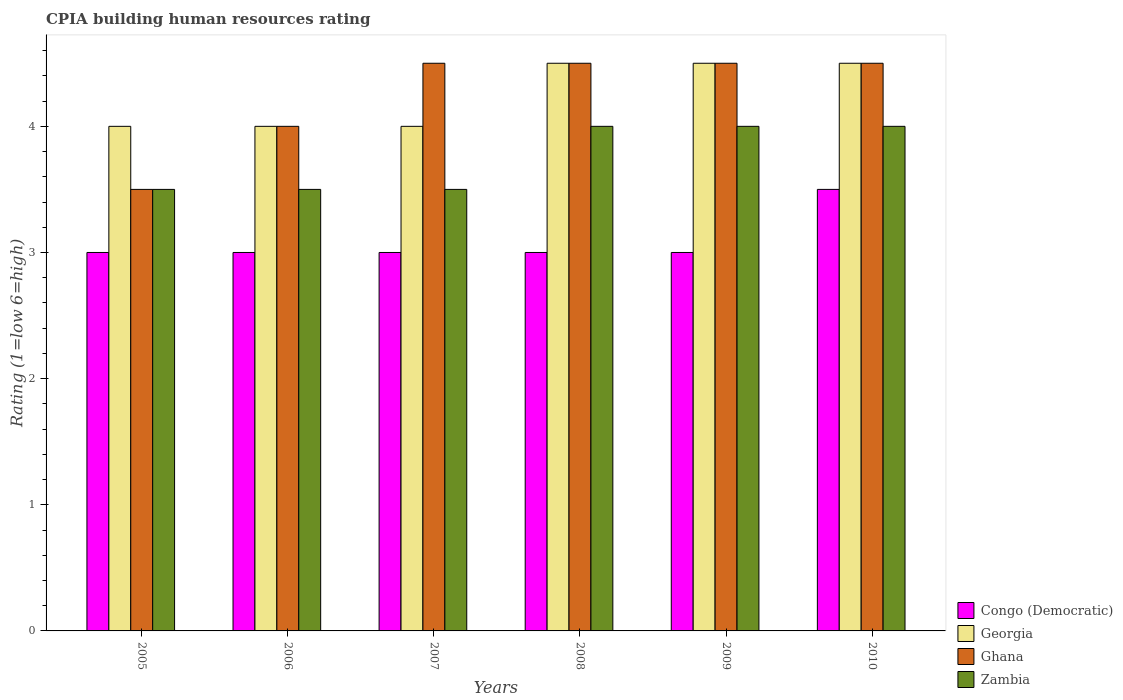How many different coloured bars are there?
Your response must be concise. 4. How many groups of bars are there?
Keep it short and to the point. 6. Are the number of bars per tick equal to the number of legend labels?
Your response must be concise. Yes. In how many cases, is the number of bars for a given year not equal to the number of legend labels?
Make the answer very short. 0. In which year was the CPIA rating in Zambia minimum?
Make the answer very short. 2005. What is the difference between the CPIA rating in Georgia in 2008 and the CPIA rating in Ghana in 2006?
Provide a succinct answer. 0.5. What is the average CPIA rating in Ghana per year?
Make the answer very short. 4.25. In the year 2008, what is the difference between the CPIA rating in Ghana and CPIA rating in Zambia?
Ensure brevity in your answer.  0.5. Is the difference between the CPIA rating in Ghana in 2005 and 2008 greater than the difference between the CPIA rating in Zambia in 2005 and 2008?
Your answer should be compact. No. What is the difference between the highest and the second highest CPIA rating in Congo (Democratic)?
Offer a very short reply. 0.5. What does the 1st bar from the left in 2010 represents?
Offer a terse response. Congo (Democratic). What does the 4th bar from the right in 2006 represents?
Provide a short and direct response. Congo (Democratic). How many bars are there?
Provide a short and direct response. 24. What is the difference between two consecutive major ticks on the Y-axis?
Give a very brief answer. 1. Are the values on the major ticks of Y-axis written in scientific E-notation?
Your answer should be very brief. No. Does the graph contain any zero values?
Your answer should be very brief. No. Does the graph contain grids?
Give a very brief answer. No. What is the title of the graph?
Keep it short and to the point. CPIA building human resources rating. Does "France" appear as one of the legend labels in the graph?
Ensure brevity in your answer.  No. What is the label or title of the X-axis?
Make the answer very short. Years. What is the Rating (1=low 6=high) in Georgia in 2005?
Offer a very short reply. 4. What is the Rating (1=low 6=high) in Zambia in 2005?
Your answer should be very brief. 3.5. What is the Rating (1=low 6=high) of Congo (Democratic) in 2006?
Provide a succinct answer. 3. What is the Rating (1=low 6=high) in Georgia in 2006?
Offer a very short reply. 4. What is the Rating (1=low 6=high) of Ghana in 2006?
Offer a terse response. 4. What is the Rating (1=low 6=high) in Zambia in 2006?
Provide a succinct answer. 3.5. What is the Rating (1=low 6=high) in Congo (Democratic) in 2007?
Your answer should be compact. 3. What is the Rating (1=low 6=high) of Ghana in 2007?
Make the answer very short. 4.5. What is the Rating (1=low 6=high) in Congo (Democratic) in 2008?
Ensure brevity in your answer.  3. What is the Rating (1=low 6=high) in Georgia in 2008?
Your response must be concise. 4.5. What is the Rating (1=low 6=high) in Congo (Democratic) in 2009?
Make the answer very short. 3. What is the Rating (1=low 6=high) of Georgia in 2009?
Offer a very short reply. 4.5. What is the Rating (1=low 6=high) of Ghana in 2009?
Offer a very short reply. 4.5. What is the Rating (1=low 6=high) in Zambia in 2009?
Provide a succinct answer. 4. What is the Rating (1=low 6=high) of Ghana in 2010?
Offer a very short reply. 4.5. What is the Rating (1=low 6=high) in Zambia in 2010?
Your response must be concise. 4. Across all years, what is the maximum Rating (1=low 6=high) of Ghana?
Your answer should be very brief. 4.5. Across all years, what is the maximum Rating (1=low 6=high) in Zambia?
Your answer should be compact. 4. Across all years, what is the minimum Rating (1=low 6=high) of Georgia?
Give a very brief answer. 4. Across all years, what is the minimum Rating (1=low 6=high) of Ghana?
Provide a succinct answer. 3.5. What is the difference between the Rating (1=low 6=high) in Congo (Democratic) in 2005 and that in 2006?
Offer a terse response. 0. What is the difference between the Rating (1=low 6=high) in Georgia in 2005 and that in 2006?
Make the answer very short. 0. What is the difference between the Rating (1=low 6=high) of Ghana in 2005 and that in 2006?
Your response must be concise. -0.5. What is the difference between the Rating (1=low 6=high) of Zambia in 2005 and that in 2006?
Keep it short and to the point. 0. What is the difference between the Rating (1=low 6=high) in Congo (Democratic) in 2005 and that in 2007?
Give a very brief answer. 0. What is the difference between the Rating (1=low 6=high) in Ghana in 2005 and that in 2007?
Your response must be concise. -1. What is the difference between the Rating (1=low 6=high) in Zambia in 2005 and that in 2007?
Give a very brief answer. 0. What is the difference between the Rating (1=low 6=high) of Ghana in 2005 and that in 2008?
Your answer should be compact. -1. What is the difference between the Rating (1=low 6=high) in Zambia in 2005 and that in 2008?
Your answer should be compact. -0.5. What is the difference between the Rating (1=low 6=high) in Congo (Democratic) in 2005 and that in 2009?
Your response must be concise. 0. What is the difference between the Rating (1=low 6=high) of Georgia in 2005 and that in 2009?
Offer a terse response. -0.5. What is the difference between the Rating (1=low 6=high) of Ghana in 2005 and that in 2010?
Provide a short and direct response. -1. What is the difference between the Rating (1=low 6=high) of Congo (Democratic) in 2006 and that in 2007?
Provide a succinct answer. 0. What is the difference between the Rating (1=low 6=high) in Ghana in 2006 and that in 2007?
Keep it short and to the point. -0.5. What is the difference between the Rating (1=low 6=high) in Zambia in 2006 and that in 2007?
Provide a short and direct response. 0. What is the difference between the Rating (1=low 6=high) of Congo (Democratic) in 2006 and that in 2008?
Your answer should be very brief. 0. What is the difference between the Rating (1=low 6=high) in Congo (Democratic) in 2006 and that in 2009?
Offer a very short reply. 0. What is the difference between the Rating (1=low 6=high) of Zambia in 2006 and that in 2009?
Your response must be concise. -0.5. What is the difference between the Rating (1=low 6=high) of Georgia in 2006 and that in 2010?
Offer a very short reply. -0.5. What is the difference between the Rating (1=low 6=high) in Zambia in 2006 and that in 2010?
Your response must be concise. -0.5. What is the difference between the Rating (1=low 6=high) in Congo (Democratic) in 2007 and that in 2008?
Ensure brevity in your answer.  0. What is the difference between the Rating (1=low 6=high) in Ghana in 2007 and that in 2008?
Your response must be concise. 0. What is the difference between the Rating (1=low 6=high) in Zambia in 2007 and that in 2008?
Provide a short and direct response. -0.5. What is the difference between the Rating (1=low 6=high) in Congo (Democratic) in 2007 and that in 2009?
Provide a succinct answer. 0. What is the difference between the Rating (1=low 6=high) in Georgia in 2007 and that in 2009?
Your answer should be compact. -0.5. What is the difference between the Rating (1=low 6=high) in Congo (Democratic) in 2007 and that in 2010?
Offer a very short reply. -0.5. What is the difference between the Rating (1=low 6=high) of Georgia in 2007 and that in 2010?
Your answer should be very brief. -0.5. What is the difference between the Rating (1=low 6=high) of Zambia in 2007 and that in 2010?
Offer a terse response. -0.5. What is the difference between the Rating (1=low 6=high) of Congo (Democratic) in 2008 and that in 2009?
Offer a very short reply. 0. What is the difference between the Rating (1=low 6=high) of Ghana in 2008 and that in 2009?
Provide a short and direct response. 0. What is the difference between the Rating (1=low 6=high) in Zambia in 2008 and that in 2009?
Give a very brief answer. 0. What is the difference between the Rating (1=low 6=high) in Congo (Democratic) in 2008 and that in 2010?
Offer a terse response. -0.5. What is the difference between the Rating (1=low 6=high) of Georgia in 2008 and that in 2010?
Provide a succinct answer. 0. What is the difference between the Rating (1=low 6=high) in Ghana in 2009 and that in 2010?
Provide a succinct answer. 0. What is the difference between the Rating (1=low 6=high) in Zambia in 2009 and that in 2010?
Your answer should be compact. 0. What is the difference between the Rating (1=low 6=high) in Congo (Democratic) in 2005 and the Rating (1=low 6=high) in Georgia in 2006?
Give a very brief answer. -1. What is the difference between the Rating (1=low 6=high) of Congo (Democratic) in 2005 and the Rating (1=low 6=high) of Zambia in 2006?
Ensure brevity in your answer.  -0.5. What is the difference between the Rating (1=low 6=high) of Congo (Democratic) in 2005 and the Rating (1=low 6=high) of Zambia in 2007?
Provide a succinct answer. -0.5. What is the difference between the Rating (1=low 6=high) of Georgia in 2005 and the Rating (1=low 6=high) of Zambia in 2007?
Keep it short and to the point. 0.5. What is the difference between the Rating (1=low 6=high) of Ghana in 2005 and the Rating (1=low 6=high) of Zambia in 2007?
Offer a very short reply. 0. What is the difference between the Rating (1=low 6=high) in Congo (Democratic) in 2005 and the Rating (1=low 6=high) in Zambia in 2008?
Your response must be concise. -1. What is the difference between the Rating (1=low 6=high) of Georgia in 2005 and the Rating (1=low 6=high) of Ghana in 2008?
Your answer should be compact. -0.5. What is the difference between the Rating (1=low 6=high) of Congo (Democratic) in 2005 and the Rating (1=low 6=high) of Georgia in 2009?
Keep it short and to the point. -1.5. What is the difference between the Rating (1=low 6=high) of Congo (Democratic) in 2005 and the Rating (1=low 6=high) of Ghana in 2009?
Your answer should be compact. -1.5. What is the difference between the Rating (1=low 6=high) of Congo (Democratic) in 2005 and the Rating (1=low 6=high) of Zambia in 2009?
Provide a succinct answer. -1. What is the difference between the Rating (1=low 6=high) in Ghana in 2005 and the Rating (1=low 6=high) in Zambia in 2009?
Your response must be concise. -0.5. What is the difference between the Rating (1=low 6=high) in Georgia in 2005 and the Rating (1=low 6=high) in Zambia in 2010?
Offer a very short reply. 0. What is the difference between the Rating (1=low 6=high) of Ghana in 2005 and the Rating (1=low 6=high) of Zambia in 2010?
Your answer should be very brief. -0.5. What is the difference between the Rating (1=low 6=high) in Congo (Democratic) in 2006 and the Rating (1=low 6=high) in Georgia in 2007?
Your answer should be very brief. -1. What is the difference between the Rating (1=low 6=high) in Georgia in 2006 and the Rating (1=low 6=high) in Ghana in 2007?
Ensure brevity in your answer.  -0.5. What is the difference between the Rating (1=low 6=high) of Georgia in 2006 and the Rating (1=low 6=high) of Zambia in 2007?
Provide a succinct answer. 0.5. What is the difference between the Rating (1=low 6=high) of Ghana in 2006 and the Rating (1=low 6=high) of Zambia in 2007?
Provide a succinct answer. 0.5. What is the difference between the Rating (1=low 6=high) of Congo (Democratic) in 2006 and the Rating (1=low 6=high) of Georgia in 2008?
Your response must be concise. -1.5. What is the difference between the Rating (1=low 6=high) in Ghana in 2006 and the Rating (1=low 6=high) in Zambia in 2008?
Keep it short and to the point. 0. What is the difference between the Rating (1=low 6=high) of Congo (Democratic) in 2006 and the Rating (1=low 6=high) of Ghana in 2009?
Offer a terse response. -1.5. What is the difference between the Rating (1=low 6=high) of Congo (Democratic) in 2006 and the Rating (1=low 6=high) of Zambia in 2009?
Your answer should be compact. -1. What is the difference between the Rating (1=low 6=high) in Georgia in 2006 and the Rating (1=low 6=high) in Ghana in 2009?
Offer a very short reply. -0.5. What is the difference between the Rating (1=low 6=high) of Ghana in 2006 and the Rating (1=low 6=high) of Zambia in 2009?
Ensure brevity in your answer.  0. What is the difference between the Rating (1=low 6=high) in Congo (Democratic) in 2006 and the Rating (1=low 6=high) in Georgia in 2010?
Provide a short and direct response. -1.5. What is the difference between the Rating (1=low 6=high) in Congo (Democratic) in 2006 and the Rating (1=low 6=high) in Ghana in 2010?
Provide a succinct answer. -1.5. What is the difference between the Rating (1=low 6=high) in Congo (Democratic) in 2006 and the Rating (1=low 6=high) in Zambia in 2010?
Give a very brief answer. -1. What is the difference between the Rating (1=low 6=high) in Georgia in 2006 and the Rating (1=low 6=high) in Ghana in 2010?
Make the answer very short. -0.5. What is the difference between the Rating (1=low 6=high) of Ghana in 2006 and the Rating (1=low 6=high) of Zambia in 2010?
Provide a short and direct response. 0. What is the difference between the Rating (1=low 6=high) in Congo (Democratic) in 2007 and the Rating (1=low 6=high) in Zambia in 2008?
Give a very brief answer. -1. What is the difference between the Rating (1=low 6=high) in Georgia in 2007 and the Rating (1=low 6=high) in Ghana in 2008?
Make the answer very short. -0.5. What is the difference between the Rating (1=low 6=high) of Congo (Democratic) in 2007 and the Rating (1=low 6=high) of Georgia in 2009?
Make the answer very short. -1.5. What is the difference between the Rating (1=low 6=high) of Georgia in 2007 and the Rating (1=low 6=high) of Ghana in 2009?
Your response must be concise. -0.5. What is the difference between the Rating (1=low 6=high) in Georgia in 2007 and the Rating (1=low 6=high) in Zambia in 2009?
Your response must be concise. 0. What is the difference between the Rating (1=low 6=high) in Ghana in 2007 and the Rating (1=low 6=high) in Zambia in 2009?
Offer a terse response. 0.5. What is the difference between the Rating (1=low 6=high) in Congo (Democratic) in 2007 and the Rating (1=low 6=high) in Ghana in 2010?
Offer a terse response. -1.5. What is the difference between the Rating (1=low 6=high) in Ghana in 2007 and the Rating (1=low 6=high) in Zambia in 2010?
Make the answer very short. 0.5. What is the difference between the Rating (1=low 6=high) in Congo (Democratic) in 2008 and the Rating (1=low 6=high) in Ghana in 2009?
Your response must be concise. -1.5. What is the difference between the Rating (1=low 6=high) in Congo (Democratic) in 2008 and the Rating (1=low 6=high) in Zambia in 2009?
Your answer should be very brief. -1. What is the difference between the Rating (1=low 6=high) in Georgia in 2008 and the Rating (1=low 6=high) in Ghana in 2009?
Your response must be concise. 0. What is the difference between the Rating (1=low 6=high) of Georgia in 2008 and the Rating (1=low 6=high) of Zambia in 2009?
Your answer should be very brief. 0.5. What is the difference between the Rating (1=low 6=high) in Congo (Democratic) in 2008 and the Rating (1=low 6=high) in Georgia in 2010?
Provide a succinct answer. -1.5. What is the difference between the Rating (1=low 6=high) of Congo (Democratic) in 2008 and the Rating (1=low 6=high) of Ghana in 2010?
Your answer should be compact. -1.5. What is the difference between the Rating (1=low 6=high) of Georgia in 2008 and the Rating (1=low 6=high) of Zambia in 2010?
Your answer should be very brief. 0.5. What is the difference between the Rating (1=low 6=high) in Georgia in 2009 and the Rating (1=low 6=high) in Ghana in 2010?
Make the answer very short. 0. What is the difference between the Rating (1=low 6=high) of Georgia in 2009 and the Rating (1=low 6=high) of Zambia in 2010?
Offer a terse response. 0.5. What is the difference between the Rating (1=low 6=high) of Ghana in 2009 and the Rating (1=low 6=high) of Zambia in 2010?
Your answer should be very brief. 0.5. What is the average Rating (1=low 6=high) of Congo (Democratic) per year?
Offer a very short reply. 3.08. What is the average Rating (1=low 6=high) of Georgia per year?
Ensure brevity in your answer.  4.25. What is the average Rating (1=low 6=high) of Ghana per year?
Provide a short and direct response. 4.25. What is the average Rating (1=low 6=high) of Zambia per year?
Provide a short and direct response. 3.75. In the year 2005, what is the difference between the Rating (1=low 6=high) of Congo (Democratic) and Rating (1=low 6=high) of Georgia?
Your answer should be very brief. -1. In the year 2006, what is the difference between the Rating (1=low 6=high) in Congo (Democratic) and Rating (1=low 6=high) in Ghana?
Make the answer very short. -1. In the year 2006, what is the difference between the Rating (1=low 6=high) in Congo (Democratic) and Rating (1=low 6=high) in Zambia?
Your response must be concise. -0.5. In the year 2006, what is the difference between the Rating (1=low 6=high) in Georgia and Rating (1=low 6=high) in Ghana?
Keep it short and to the point. 0. In the year 2006, what is the difference between the Rating (1=low 6=high) of Georgia and Rating (1=low 6=high) of Zambia?
Your answer should be compact. 0.5. In the year 2007, what is the difference between the Rating (1=low 6=high) of Congo (Democratic) and Rating (1=low 6=high) of Ghana?
Your response must be concise. -1.5. In the year 2007, what is the difference between the Rating (1=low 6=high) in Georgia and Rating (1=low 6=high) in Zambia?
Make the answer very short. 0.5. In the year 2008, what is the difference between the Rating (1=low 6=high) of Congo (Democratic) and Rating (1=low 6=high) of Georgia?
Offer a terse response. -1.5. In the year 2008, what is the difference between the Rating (1=low 6=high) in Georgia and Rating (1=low 6=high) in Ghana?
Offer a very short reply. 0. In the year 2008, what is the difference between the Rating (1=low 6=high) of Ghana and Rating (1=low 6=high) of Zambia?
Provide a short and direct response. 0.5. In the year 2009, what is the difference between the Rating (1=low 6=high) of Congo (Democratic) and Rating (1=low 6=high) of Georgia?
Make the answer very short. -1.5. In the year 2009, what is the difference between the Rating (1=low 6=high) of Congo (Democratic) and Rating (1=low 6=high) of Ghana?
Provide a succinct answer. -1.5. In the year 2009, what is the difference between the Rating (1=low 6=high) of Ghana and Rating (1=low 6=high) of Zambia?
Offer a very short reply. 0.5. In the year 2010, what is the difference between the Rating (1=low 6=high) of Congo (Democratic) and Rating (1=low 6=high) of Ghana?
Make the answer very short. -1. In the year 2010, what is the difference between the Rating (1=low 6=high) of Congo (Democratic) and Rating (1=low 6=high) of Zambia?
Offer a terse response. -0.5. What is the ratio of the Rating (1=low 6=high) in Georgia in 2005 to that in 2006?
Provide a short and direct response. 1. What is the ratio of the Rating (1=low 6=high) in Zambia in 2005 to that in 2006?
Your response must be concise. 1. What is the ratio of the Rating (1=low 6=high) of Congo (Democratic) in 2005 to that in 2007?
Your response must be concise. 1. What is the ratio of the Rating (1=low 6=high) of Georgia in 2005 to that in 2007?
Your response must be concise. 1. What is the ratio of the Rating (1=low 6=high) in Ghana in 2005 to that in 2007?
Offer a terse response. 0.78. What is the ratio of the Rating (1=low 6=high) of Ghana in 2005 to that in 2008?
Provide a short and direct response. 0.78. What is the ratio of the Rating (1=low 6=high) in Zambia in 2005 to that in 2008?
Your answer should be compact. 0.88. What is the ratio of the Rating (1=low 6=high) of Congo (Democratic) in 2005 to that in 2009?
Your answer should be very brief. 1. What is the ratio of the Rating (1=low 6=high) of Ghana in 2005 to that in 2009?
Ensure brevity in your answer.  0.78. What is the ratio of the Rating (1=low 6=high) of Congo (Democratic) in 2005 to that in 2010?
Provide a succinct answer. 0.86. What is the ratio of the Rating (1=low 6=high) of Congo (Democratic) in 2006 to that in 2007?
Give a very brief answer. 1. What is the ratio of the Rating (1=low 6=high) in Ghana in 2006 to that in 2007?
Your answer should be very brief. 0.89. What is the ratio of the Rating (1=low 6=high) of Zambia in 2006 to that in 2007?
Ensure brevity in your answer.  1. What is the ratio of the Rating (1=low 6=high) in Ghana in 2006 to that in 2008?
Your answer should be very brief. 0.89. What is the ratio of the Rating (1=low 6=high) in Congo (Democratic) in 2006 to that in 2009?
Ensure brevity in your answer.  1. What is the ratio of the Rating (1=low 6=high) in Georgia in 2006 to that in 2009?
Offer a very short reply. 0.89. What is the ratio of the Rating (1=low 6=high) in Ghana in 2006 to that in 2009?
Keep it short and to the point. 0.89. What is the ratio of the Rating (1=low 6=high) of Congo (Democratic) in 2006 to that in 2010?
Your response must be concise. 0.86. What is the ratio of the Rating (1=low 6=high) of Georgia in 2006 to that in 2010?
Offer a very short reply. 0.89. What is the ratio of the Rating (1=low 6=high) in Ghana in 2006 to that in 2010?
Offer a terse response. 0.89. What is the ratio of the Rating (1=low 6=high) of Zambia in 2007 to that in 2008?
Offer a terse response. 0.88. What is the ratio of the Rating (1=low 6=high) of Congo (Democratic) in 2007 to that in 2009?
Your response must be concise. 1. What is the ratio of the Rating (1=low 6=high) in Ghana in 2007 to that in 2009?
Offer a terse response. 1. What is the ratio of the Rating (1=low 6=high) of Zambia in 2007 to that in 2009?
Make the answer very short. 0.88. What is the ratio of the Rating (1=low 6=high) in Zambia in 2008 to that in 2009?
Keep it short and to the point. 1. What is the ratio of the Rating (1=low 6=high) in Congo (Democratic) in 2008 to that in 2010?
Your response must be concise. 0.86. What is the ratio of the Rating (1=low 6=high) in Georgia in 2008 to that in 2010?
Your answer should be very brief. 1. What is the ratio of the Rating (1=low 6=high) in Zambia in 2008 to that in 2010?
Your answer should be compact. 1. What is the ratio of the Rating (1=low 6=high) of Georgia in 2009 to that in 2010?
Keep it short and to the point. 1. What is the difference between the highest and the second highest Rating (1=low 6=high) in Zambia?
Provide a succinct answer. 0. What is the difference between the highest and the lowest Rating (1=low 6=high) in Georgia?
Keep it short and to the point. 0.5. 